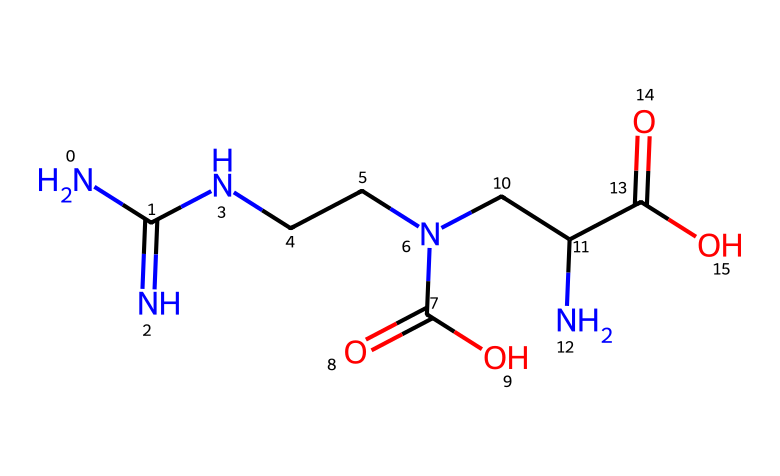What is the molecular formula of creatine? To find the molecular formula, we need to count the atoms of each element in the SMILES representation. From the representation, we see there are 6 carbon (C) atoms, 13 hydrogen (H) atoms, 3 nitrogen (N) atoms, and 4 oxygen (O) atoms. Combining these counts gives us C6H13N3O4.
Answer: C6H13N3O4 How many nitrogen atoms are present in creatine? By analyzing the SMILES representation, we can identify each nitrogen (N) atom. There are 3 instances of nitrogen in the structure. Thus, the total count of nitrogen atoms is 3.
Answer: 3 What is the role of creatine in muscle recovery? Creatine primarily serves as an energy reservoir in muscle cells through its conversion to creatine phosphate, which quickly regenerates ATP during high-intensity exercise, helping with muscle recovery and performance.
Answer: energy reservoir Which group is primarily responsible for creatine's solubility in water? The presence of the carboxylic acid group (-COOH) in the structure of creatine enhances its solubility in water due to hydrogen bonding, as this group can interact with water molecules.
Answer: carboxylic acid group What type of biochemical is creatine classified as? Creatine is classified as an amino acid derivative, as it contains elements typical of amino acids (such as nitrogen and a carboxylic group) but is not a standard amino acid itself.
Answer: amino acid derivative What does the presence of multiple nitrogen atoms imply about creatine's properties? The multiple nitrogen atoms indicate that creatine can participate in various biochemical reactions, particularly in energy metabolism and as a nitrogen donor in synthesizing other biomolecules, affecting its functionality.
Answer: biochemical reactivity 